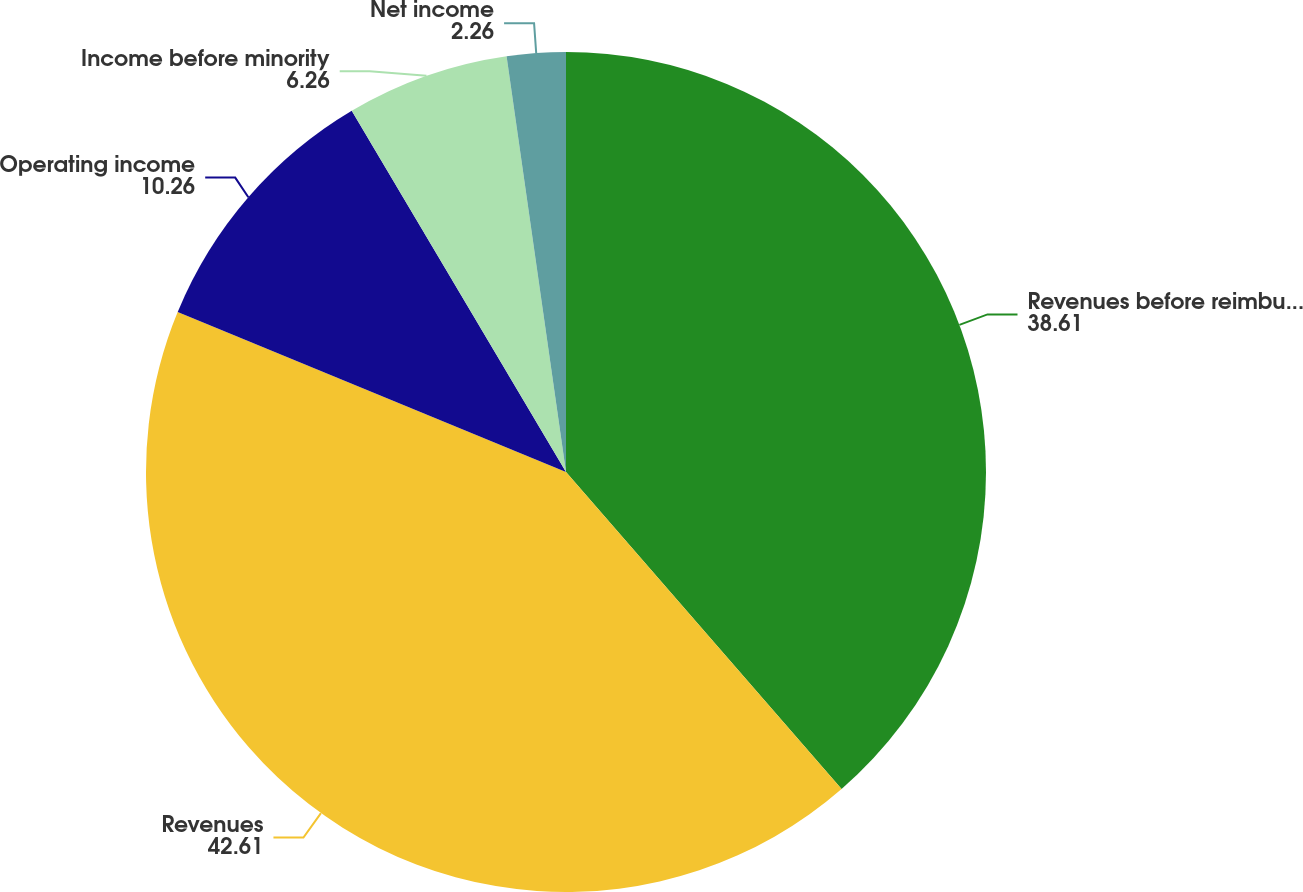Convert chart to OTSL. <chart><loc_0><loc_0><loc_500><loc_500><pie_chart><fcel>Revenues before reimbursements<fcel>Revenues<fcel>Operating income<fcel>Income before minority<fcel>Net income<nl><fcel>38.61%<fcel>42.61%<fcel>10.26%<fcel>6.26%<fcel>2.26%<nl></chart> 